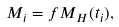<formula> <loc_0><loc_0><loc_500><loc_500>M _ { i } = f M _ { H } ( t _ { i } ) ,</formula> 